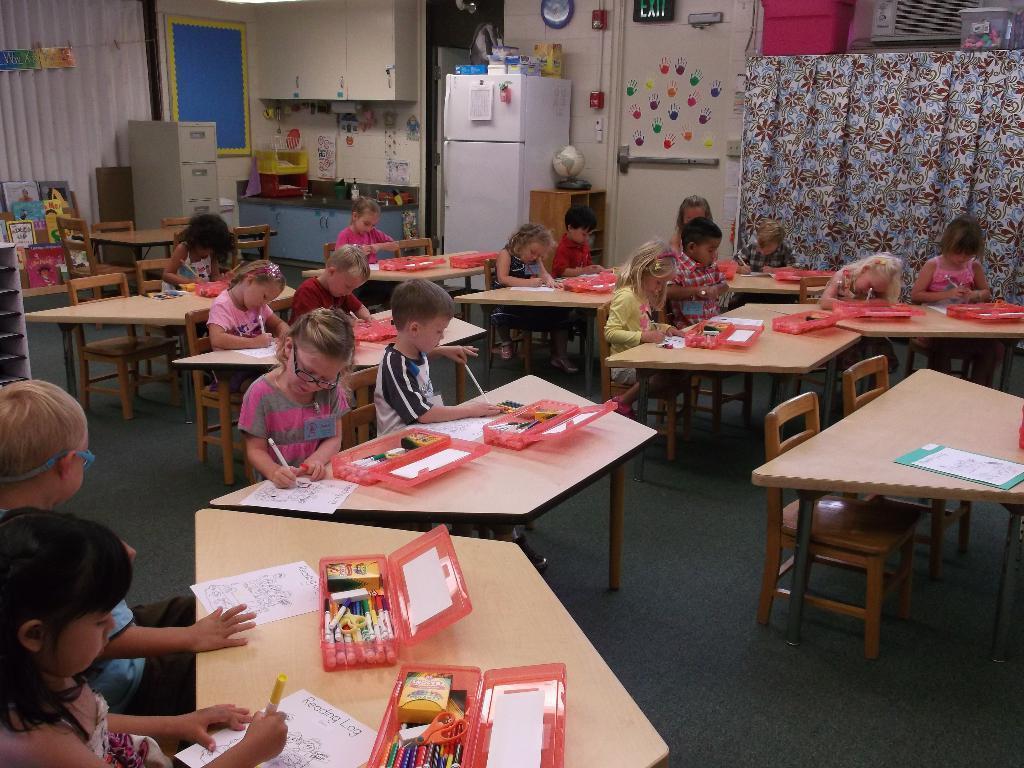Describe this image in one or two sentences. In this picture there are children sitting and coloring a picture which is given on the paper and there is a refrigerator and the curtain over here 